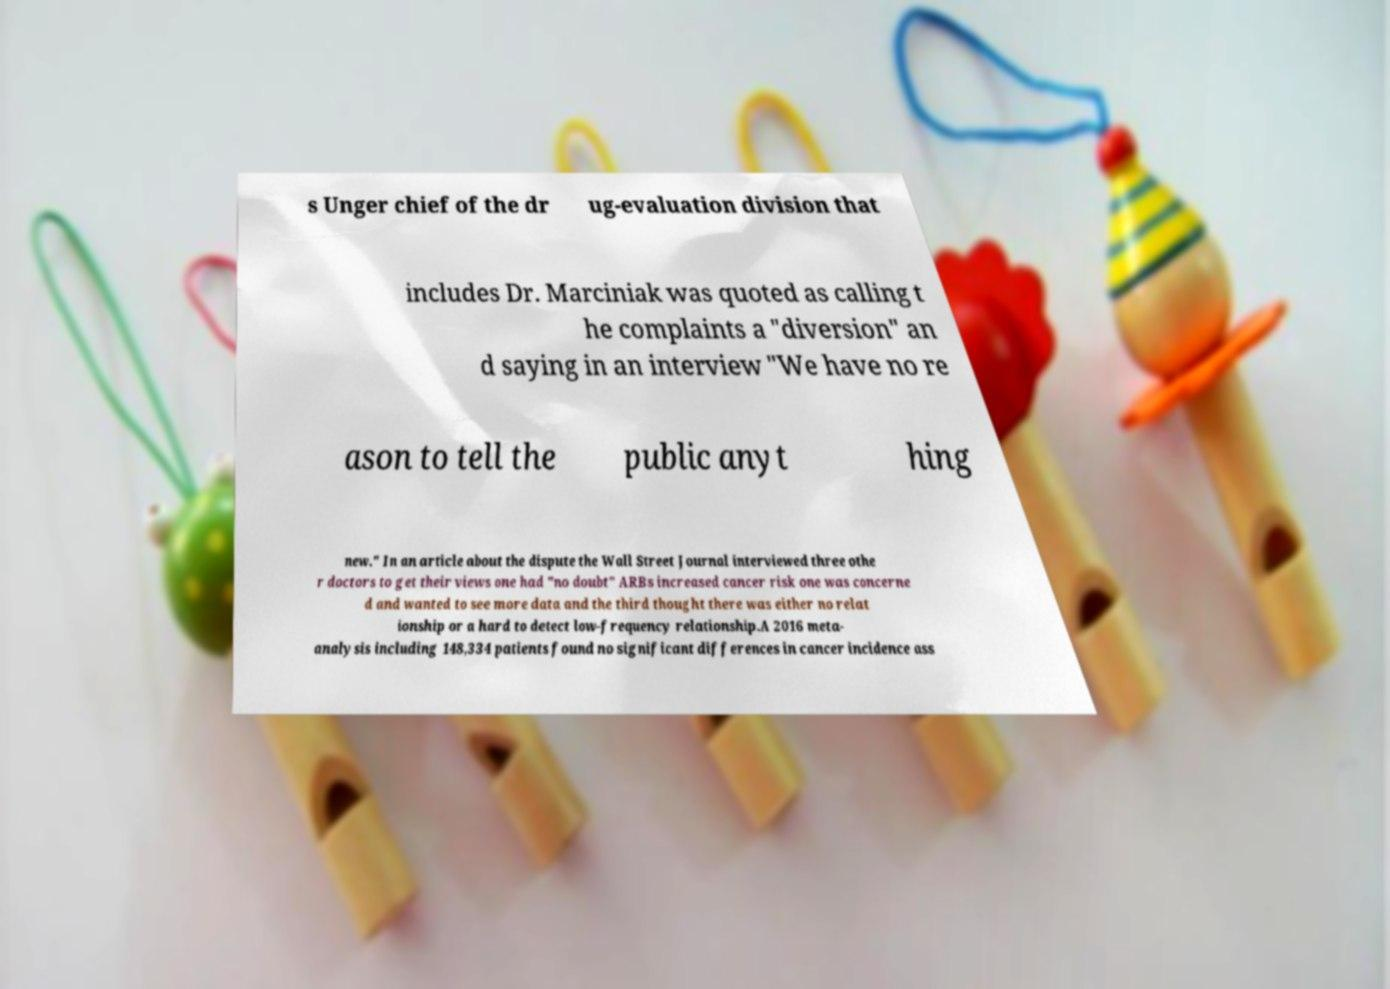Could you assist in decoding the text presented in this image and type it out clearly? s Unger chief of the dr ug-evaluation division that includes Dr. Marciniak was quoted as calling t he complaints a "diversion" an d saying in an interview "We have no re ason to tell the public anyt hing new." In an article about the dispute the Wall Street Journal interviewed three othe r doctors to get their views one had "no doubt" ARBs increased cancer risk one was concerne d and wanted to see more data and the third thought there was either no relat ionship or a hard to detect low-frequency relationship.A 2016 meta- analysis including 148,334 patients found no significant differences in cancer incidence ass 